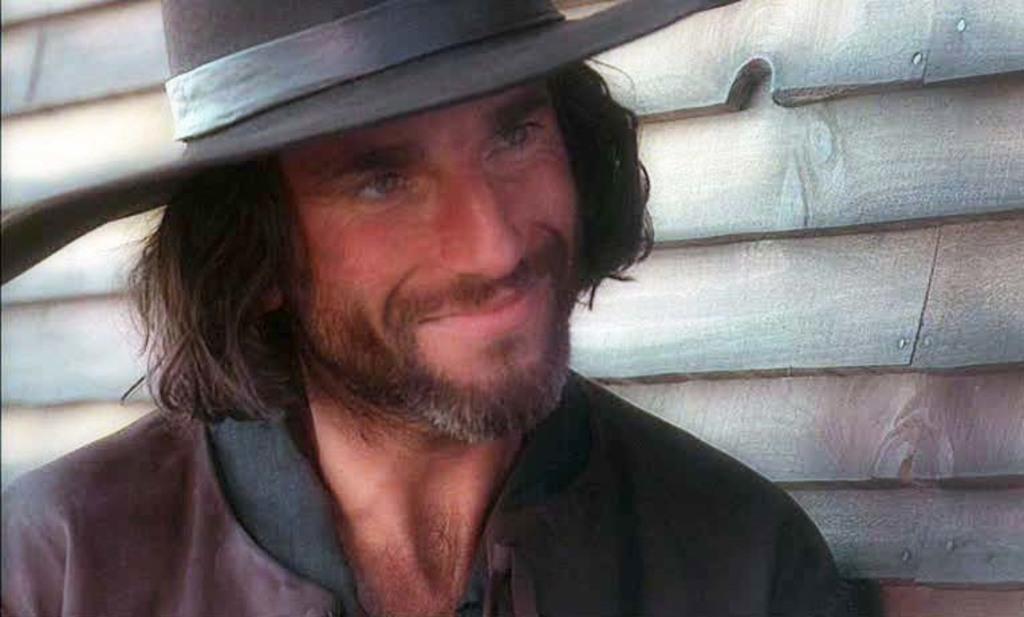In one or two sentences, can you explain what this image depicts? In this image I can see a person wearing brown and black colored dress and black colored hat. In the background I can see the wooden wall. 